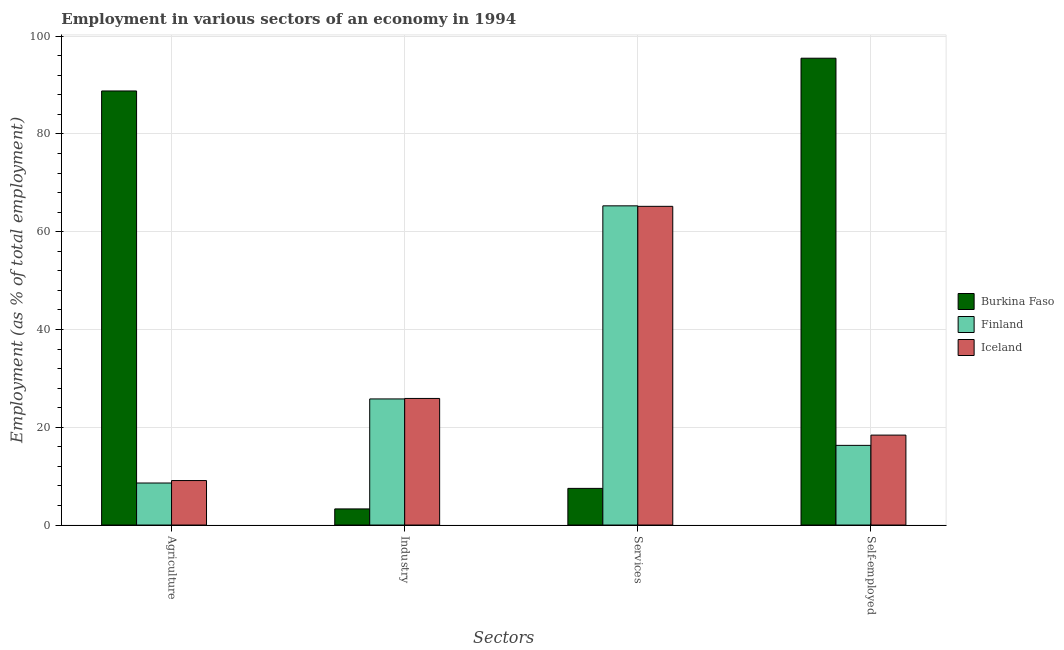How many groups of bars are there?
Provide a succinct answer. 4. Are the number of bars per tick equal to the number of legend labels?
Make the answer very short. Yes. How many bars are there on the 2nd tick from the left?
Offer a terse response. 3. What is the label of the 2nd group of bars from the left?
Offer a very short reply. Industry. What is the percentage of workers in services in Iceland?
Your answer should be compact. 65.2. Across all countries, what is the maximum percentage of workers in services?
Offer a terse response. 65.3. In which country was the percentage of workers in agriculture maximum?
Your answer should be very brief. Burkina Faso. In which country was the percentage of workers in services minimum?
Offer a terse response. Burkina Faso. What is the total percentage of workers in services in the graph?
Keep it short and to the point. 138. What is the difference between the percentage of workers in agriculture in Burkina Faso and that in Iceland?
Keep it short and to the point. 79.7. What is the difference between the percentage of self employed workers in Finland and the percentage of workers in agriculture in Iceland?
Ensure brevity in your answer.  7.2. What is the average percentage of workers in services per country?
Keep it short and to the point. 46. What is the difference between the percentage of workers in services and percentage of workers in industry in Finland?
Your response must be concise. 39.5. What is the ratio of the percentage of workers in industry in Finland to that in Burkina Faso?
Your answer should be compact. 7.82. Is the percentage of workers in agriculture in Iceland less than that in Burkina Faso?
Provide a succinct answer. Yes. Is the difference between the percentage of workers in industry in Burkina Faso and Finland greater than the difference between the percentage of workers in agriculture in Burkina Faso and Finland?
Your response must be concise. No. What is the difference between the highest and the second highest percentage of workers in industry?
Give a very brief answer. 0.1. What is the difference between the highest and the lowest percentage of self employed workers?
Provide a succinct answer. 79.2. What does the 3rd bar from the right in Services represents?
Your answer should be compact. Burkina Faso. Is it the case that in every country, the sum of the percentage of workers in agriculture and percentage of workers in industry is greater than the percentage of workers in services?
Provide a short and direct response. No. Are all the bars in the graph horizontal?
Provide a short and direct response. No. What is the difference between two consecutive major ticks on the Y-axis?
Your response must be concise. 20. Does the graph contain any zero values?
Provide a succinct answer. No. Does the graph contain grids?
Your response must be concise. Yes. Where does the legend appear in the graph?
Offer a terse response. Center right. How many legend labels are there?
Your answer should be compact. 3. How are the legend labels stacked?
Provide a succinct answer. Vertical. What is the title of the graph?
Your answer should be compact. Employment in various sectors of an economy in 1994. Does "Saudi Arabia" appear as one of the legend labels in the graph?
Keep it short and to the point. No. What is the label or title of the X-axis?
Provide a short and direct response. Sectors. What is the label or title of the Y-axis?
Ensure brevity in your answer.  Employment (as % of total employment). What is the Employment (as % of total employment) of Burkina Faso in Agriculture?
Provide a succinct answer. 88.8. What is the Employment (as % of total employment) in Finland in Agriculture?
Provide a succinct answer. 8.6. What is the Employment (as % of total employment) in Iceland in Agriculture?
Give a very brief answer. 9.1. What is the Employment (as % of total employment) of Burkina Faso in Industry?
Offer a terse response. 3.3. What is the Employment (as % of total employment) of Finland in Industry?
Your answer should be compact. 25.8. What is the Employment (as % of total employment) in Iceland in Industry?
Your response must be concise. 25.9. What is the Employment (as % of total employment) of Finland in Services?
Provide a succinct answer. 65.3. What is the Employment (as % of total employment) in Iceland in Services?
Ensure brevity in your answer.  65.2. What is the Employment (as % of total employment) in Burkina Faso in Self-employed?
Ensure brevity in your answer.  95.5. What is the Employment (as % of total employment) of Finland in Self-employed?
Keep it short and to the point. 16.3. What is the Employment (as % of total employment) in Iceland in Self-employed?
Keep it short and to the point. 18.4. Across all Sectors, what is the maximum Employment (as % of total employment) of Burkina Faso?
Give a very brief answer. 95.5. Across all Sectors, what is the maximum Employment (as % of total employment) of Finland?
Provide a short and direct response. 65.3. Across all Sectors, what is the maximum Employment (as % of total employment) in Iceland?
Keep it short and to the point. 65.2. Across all Sectors, what is the minimum Employment (as % of total employment) of Burkina Faso?
Your response must be concise. 3.3. Across all Sectors, what is the minimum Employment (as % of total employment) in Finland?
Make the answer very short. 8.6. Across all Sectors, what is the minimum Employment (as % of total employment) in Iceland?
Offer a terse response. 9.1. What is the total Employment (as % of total employment) of Burkina Faso in the graph?
Keep it short and to the point. 195.1. What is the total Employment (as % of total employment) of Finland in the graph?
Your answer should be very brief. 116. What is the total Employment (as % of total employment) of Iceland in the graph?
Make the answer very short. 118.6. What is the difference between the Employment (as % of total employment) in Burkina Faso in Agriculture and that in Industry?
Your response must be concise. 85.5. What is the difference between the Employment (as % of total employment) of Finland in Agriculture and that in Industry?
Offer a terse response. -17.2. What is the difference between the Employment (as % of total employment) in Iceland in Agriculture and that in Industry?
Your answer should be compact. -16.8. What is the difference between the Employment (as % of total employment) in Burkina Faso in Agriculture and that in Services?
Your answer should be compact. 81.3. What is the difference between the Employment (as % of total employment) of Finland in Agriculture and that in Services?
Your response must be concise. -56.7. What is the difference between the Employment (as % of total employment) in Iceland in Agriculture and that in Services?
Your response must be concise. -56.1. What is the difference between the Employment (as % of total employment) in Burkina Faso in Agriculture and that in Self-employed?
Provide a succinct answer. -6.7. What is the difference between the Employment (as % of total employment) in Iceland in Agriculture and that in Self-employed?
Ensure brevity in your answer.  -9.3. What is the difference between the Employment (as % of total employment) in Burkina Faso in Industry and that in Services?
Provide a succinct answer. -4.2. What is the difference between the Employment (as % of total employment) of Finland in Industry and that in Services?
Give a very brief answer. -39.5. What is the difference between the Employment (as % of total employment) in Iceland in Industry and that in Services?
Your answer should be compact. -39.3. What is the difference between the Employment (as % of total employment) of Burkina Faso in Industry and that in Self-employed?
Ensure brevity in your answer.  -92.2. What is the difference between the Employment (as % of total employment) of Burkina Faso in Services and that in Self-employed?
Your answer should be very brief. -88. What is the difference between the Employment (as % of total employment) of Finland in Services and that in Self-employed?
Your answer should be very brief. 49. What is the difference between the Employment (as % of total employment) of Iceland in Services and that in Self-employed?
Give a very brief answer. 46.8. What is the difference between the Employment (as % of total employment) of Burkina Faso in Agriculture and the Employment (as % of total employment) of Finland in Industry?
Keep it short and to the point. 63. What is the difference between the Employment (as % of total employment) of Burkina Faso in Agriculture and the Employment (as % of total employment) of Iceland in Industry?
Give a very brief answer. 62.9. What is the difference between the Employment (as % of total employment) in Finland in Agriculture and the Employment (as % of total employment) in Iceland in Industry?
Provide a short and direct response. -17.3. What is the difference between the Employment (as % of total employment) in Burkina Faso in Agriculture and the Employment (as % of total employment) in Iceland in Services?
Offer a terse response. 23.6. What is the difference between the Employment (as % of total employment) of Finland in Agriculture and the Employment (as % of total employment) of Iceland in Services?
Give a very brief answer. -56.6. What is the difference between the Employment (as % of total employment) of Burkina Faso in Agriculture and the Employment (as % of total employment) of Finland in Self-employed?
Offer a very short reply. 72.5. What is the difference between the Employment (as % of total employment) in Burkina Faso in Agriculture and the Employment (as % of total employment) in Iceland in Self-employed?
Provide a succinct answer. 70.4. What is the difference between the Employment (as % of total employment) of Finland in Agriculture and the Employment (as % of total employment) of Iceland in Self-employed?
Give a very brief answer. -9.8. What is the difference between the Employment (as % of total employment) in Burkina Faso in Industry and the Employment (as % of total employment) in Finland in Services?
Keep it short and to the point. -62. What is the difference between the Employment (as % of total employment) in Burkina Faso in Industry and the Employment (as % of total employment) in Iceland in Services?
Offer a very short reply. -61.9. What is the difference between the Employment (as % of total employment) in Finland in Industry and the Employment (as % of total employment) in Iceland in Services?
Your answer should be compact. -39.4. What is the difference between the Employment (as % of total employment) of Burkina Faso in Industry and the Employment (as % of total employment) of Finland in Self-employed?
Ensure brevity in your answer.  -13. What is the difference between the Employment (as % of total employment) in Burkina Faso in Industry and the Employment (as % of total employment) in Iceland in Self-employed?
Your answer should be very brief. -15.1. What is the difference between the Employment (as % of total employment) of Finland in Industry and the Employment (as % of total employment) of Iceland in Self-employed?
Your answer should be compact. 7.4. What is the difference between the Employment (as % of total employment) of Finland in Services and the Employment (as % of total employment) of Iceland in Self-employed?
Provide a short and direct response. 46.9. What is the average Employment (as % of total employment) in Burkina Faso per Sectors?
Offer a very short reply. 48.77. What is the average Employment (as % of total employment) of Iceland per Sectors?
Your answer should be compact. 29.65. What is the difference between the Employment (as % of total employment) in Burkina Faso and Employment (as % of total employment) in Finland in Agriculture?
Your response must be concise. 80.2. What is the difference between the Employment (as % of total employment) in Burkina Faso and Employment (as % of total employment) in Iceland in Agriculture?
Provide a short and direct response. 79.7. What is the difference between the Employment (as % of total employment) of Finland and Employment (as % of total employment) of Iceland in Agriculture?
Ensure brevity in your answer.  -0.5. What is the difference between the Employment (as % of total employment) of Burkina Faso and Employment (as % of total employment) of Finland in Industry?
Provide a succinct answer. -22.5. What is the difference between the Employment (as % of total employment) in Burkina Faso and Employment (as % of total employment) in Iceland in Industry?
Your response must be concise. -22.6. What is the difference between the Employment (as % of total employment) of Finland and Employment (as % of total employment) of Iceland in Industry?
Your answer should be compact. -0.1. What is the difference between the Employment (as % of total employment) in Burkina Faso and Employment (as % of total employment) in Finland in Services?
Ensure brevity in your answer.  -57.8. What is the difference between the Employment (as % of total employment) in Burkina Faso and Employment (as % of total employment) in Iceland in Services?
Ensure brevity in your answer.  -57.7. What is the difference between the Employment (as % of total employment) of Finland and Employment (as % of total employment) of Iceland in Services?
Provide a short and direct response. 0.1. What is the difference between the Employment (as % of total employment) of Burkina Faso and Employment (as % of total employment) of Finland in Self-employed?
Give a very brief answer. 79.2. What is the difference between the Employment (as % of total employment) of Burkina Faso and Employment (as % of total employment) of Iceland in Self-employed?
Offer a terse response. 77.1. What is the difference between the Employment (as % of total employment) of Finland and Employment (as % of total employment) of Iceland in Self-employed?
Offer a very short reply. -2.1. What is the ratio of the Employment (as % of total employment) in Burkina Faso in Agriculture to that in Industry?
Provide a short and direct response. 26.91. What is the ratio of the Employment (as % of total employment) in Finland in Agriculture to that in Industry?
Keep it short and to the point. 0.33. What is the ratio of the Employment (as % of total employment) in Iceland in Agriculture to that in Industry?
Keep it short and to the point. 0.35. What is the ratio of the Employment (as % of total employment) of Burkina Faso in Agriculture to that in Services?
Ensure brevity in your answer.  11.84. What is the ratio of the Employment (as % of total employment) in Finland in Agriculture to that in Services?
Offer a very short reply. 0.13. What is the ratio of the Employment (as % of total employment) in Iceland in Agriculture to that in Services?
Offer a terse response. 0.14. What is the ratio of the Employment (as % of total employment) in Burkina Faso in Agriculture to that in Self-employed?
Your answer should be very brief. 0.93. What is the ratio of the Employment (as % of total employment) in Finland in Agriculture to that in Self-employed?
Your response must be concise. 0.53. What is the ratio of the Employment (as % of total employment) in Iceland in Agriculture to that in Self-employed?
Give a very brief answer. 0.49. What is the ratio of the Employment (as % of total employment) of Burkina Faso in Industry to that in Services?
Your response must be concise. 0.44. What is the ratio of the Employment (as % of total employment) in Finland in Industry to that in Services?
Provide a short and direct response. 0.4. What is the ratio of the Employment (as % of total employment) in Iceland in Industry to that in Services?
Ensure brevity in your answer.  0.4. What is the ratio of the Employment (as % of total employment) of Burkina Faso in Industry to that in Self-employed?
Offer a terse response. 0.03. What is the ratio of the Employment (as % of total employment) of Finland in Industry to that in Self-employed?
Provide a succinct answer. 1.58. What is the ratio of the Employment (as % of total employment) of Iceland in Industry to that in Self-employed?
Offer a terse response. 1.41. What is the ratio of the Employment (as % of total employment) in Burkina Faso in Services to that in Self-employed?
Give a very brief answer. 0.08. What is the ratio of the Employment (as % of total employment) in Finland in Services to that in Self-employed?
Provide a short and direct response. 4.01. What is the ratio of the Employment (as % of total employment) in Iceland in Services to that in Self-employed?
Keep it short and to the point. 3.54. What is the difference between the highest and the second highest Employment (as % of total employment) of Burkina Faso?
Give a very brief answer. 6.7. What is the difference between the highest and the second highest Employment (as % of total employment) in Finland?
Your answer should be compact. 39.5. What is the difference between the highest and the second highest Employment (as % of total employment) of Iceland?
Ensure brevity in your answer.  39.3. What is the difference between the highest and the lowest Employment (as % of total employment) in Burkina Faso?
Provide a succinct answer. 92.2. What is the difference between the highest and the lowest Employment (as % of total employment) of Finland?
Provide a short and direct response. 56.7. What is the difference between the highest and the lowest Employment (as % of total employment) in Iceland?
Provide a short and direct response. 56.1. 